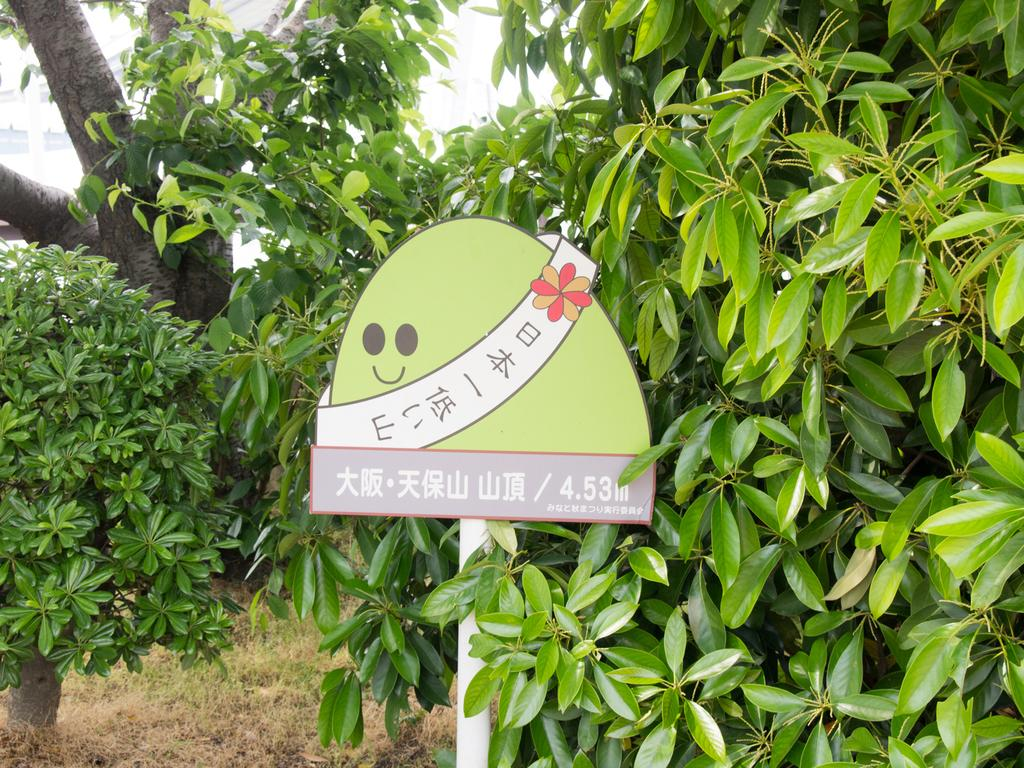What is the main object in the image? There is a board in the image. What type of natural environment is visible in the image? There is grass and trees visible in the image. What type of farm animals can be seen grazing on the grass in the image? There are no farm animals visible in the image; it only features a board, grass, and trees. 